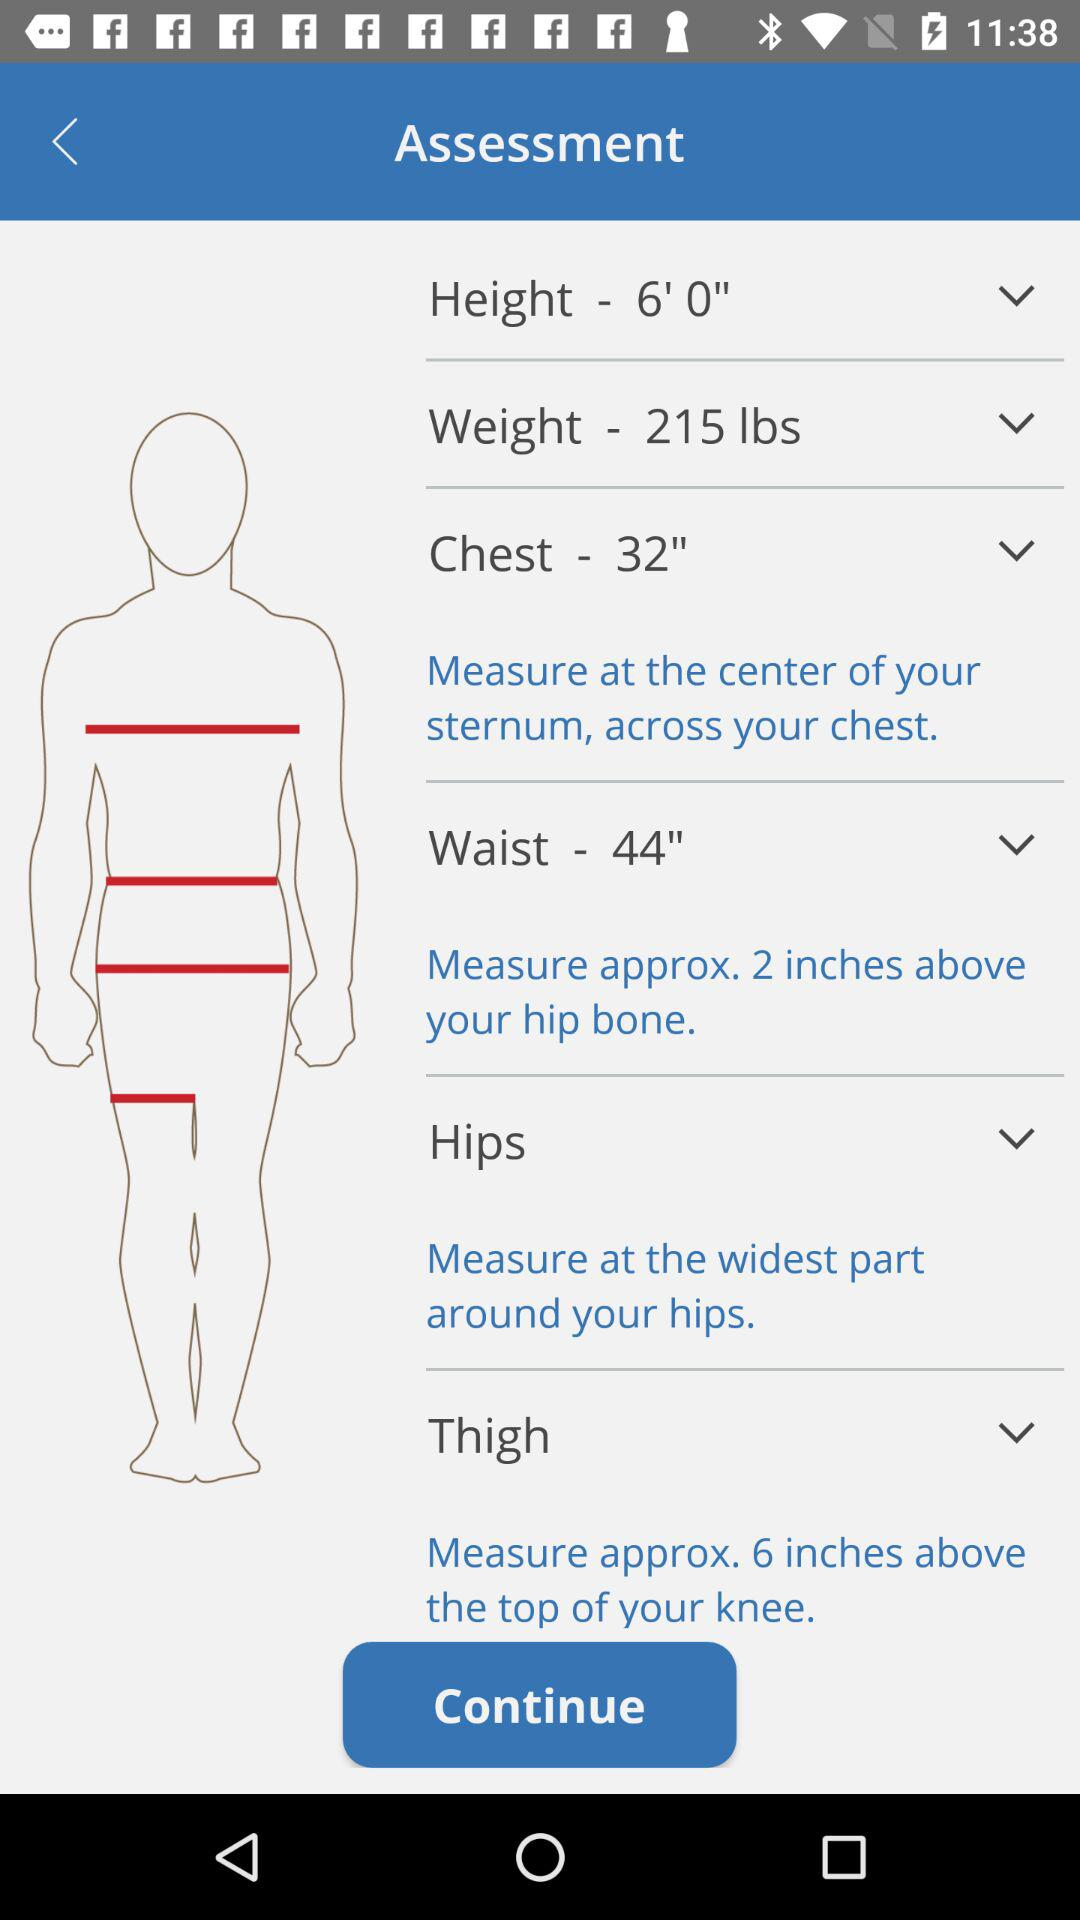What is the selected weight? The selected weight is 215 pounds. 